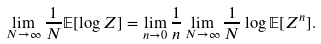Convert formula to latex. <formula><loc_0><loc_0><loc_500><loc_500>\lim _ { N \to \infty } \frac { 1 } { N } \mathbb { E } [ \log Z ] = \lim _ { n \to 0 } \frac { 1 } { n } \lim _ { N \to \infty } \frac { 1 } { N } \log \mathbb { E } [ Z ^ { n } ] .</formula> 